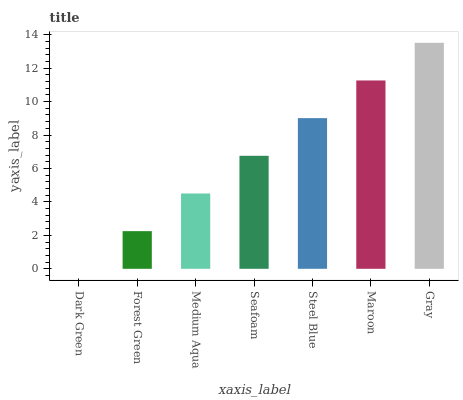Is Forest Green the minimum?
Answer yes or no. No. Is Forest Green the maximum?
Answer yes or no. No. Is Forest Green greater than Dark Green?
Answer yes or no. Yes. Is Dark Green less than Forest Green?
Answer yes or no. Yes. Is Dark Green greater than Forest Green?
Answer yes or no. No. Is Forest Green less than Dark Green?
Answer yes or no. No. Is Seafoam the high median?
Answer yes or no. Yes. Is Seafoam the low median?
Answer yes or no. Yes. Is Gray the high median?
Answer yes or no. No. Is Gray the low median?
Answer yes or no. No. 